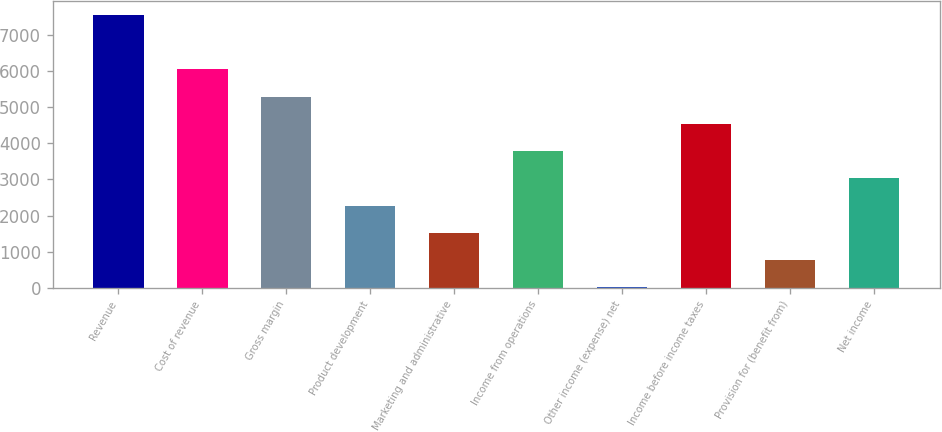Convert chart. <chart><loc_0><loc_0><loc_500><loc_500><bar_chart><fcel>Revenue<fcel>Cost of revenue<fcel>Gross margin<fcel>Product development<fcel>Marketing and administrative<fcel>Income from operations<fcel>Other income (expense) net<fcel>Income before income taxes<fcel>Provision for (benefit from)<fcel>Net income<nl><fcel>7553<fcel>6044.4<fcel>5290.1<fcel>2272.9<fcel>1518.6<fcel>3781.5<fcel>10<fcel>4535.8<fcel>764.3<fcel>3027.2<nl></chart> 